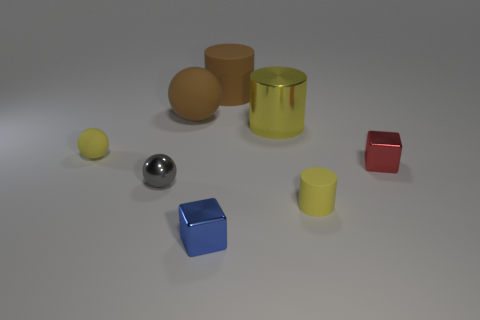Subtract all red balls. Subtract all green cylinders. How many balls are left? 3 Add 1 large spheres. How many objects exist? 9 Subtract all cubes. How many objects are left? 6 Add 2 metallic cubes. How many metallic cubes are left? 4 Add 6 large yellow cylinders. How many large yellow cylinders exist? 7 Subtract 0 brown cubes. How many objects are left? 8 Subtract all metal things. Subtract all yellow shiny cylinders. How many objects are left? 3 